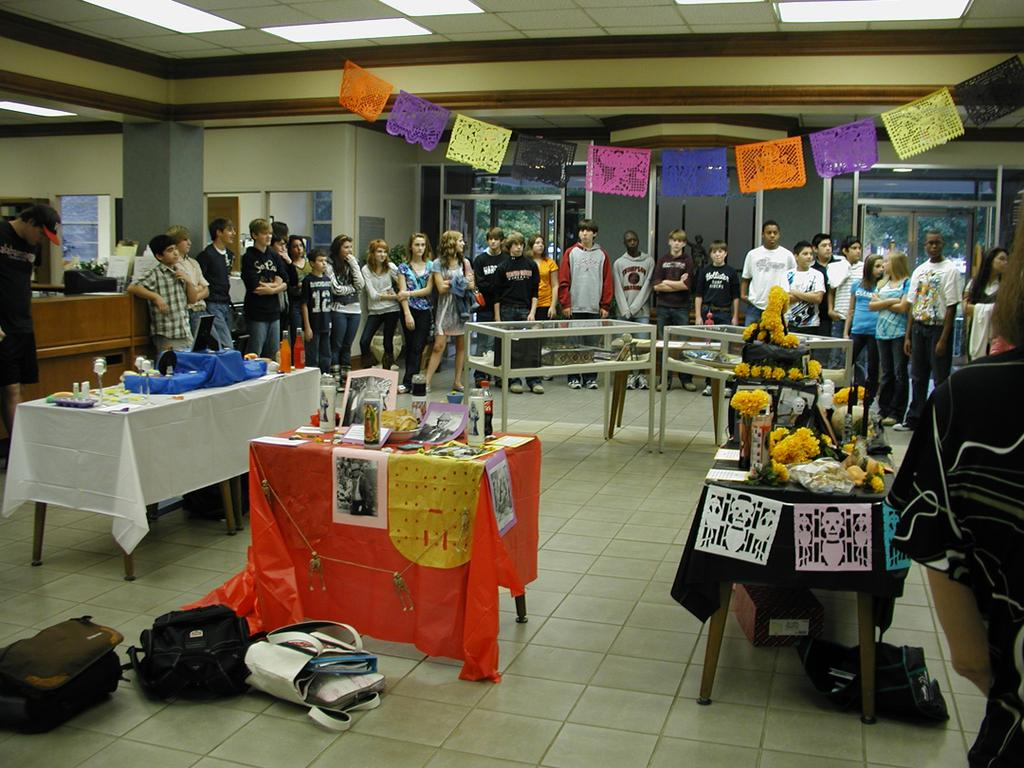How many people are in the image? There is a group of people standing in the image. What is the surface the people are standing on? The people are standing on the floor. What is present on the floor besides the people? There are bags on the floor. What is on the table in the image? There is a bottle and paper material on the table. What type of alarm is going off in the image? There is no alarm present in the image. What type of business is being conducted in the image? The image does not depict any specific business activity. 